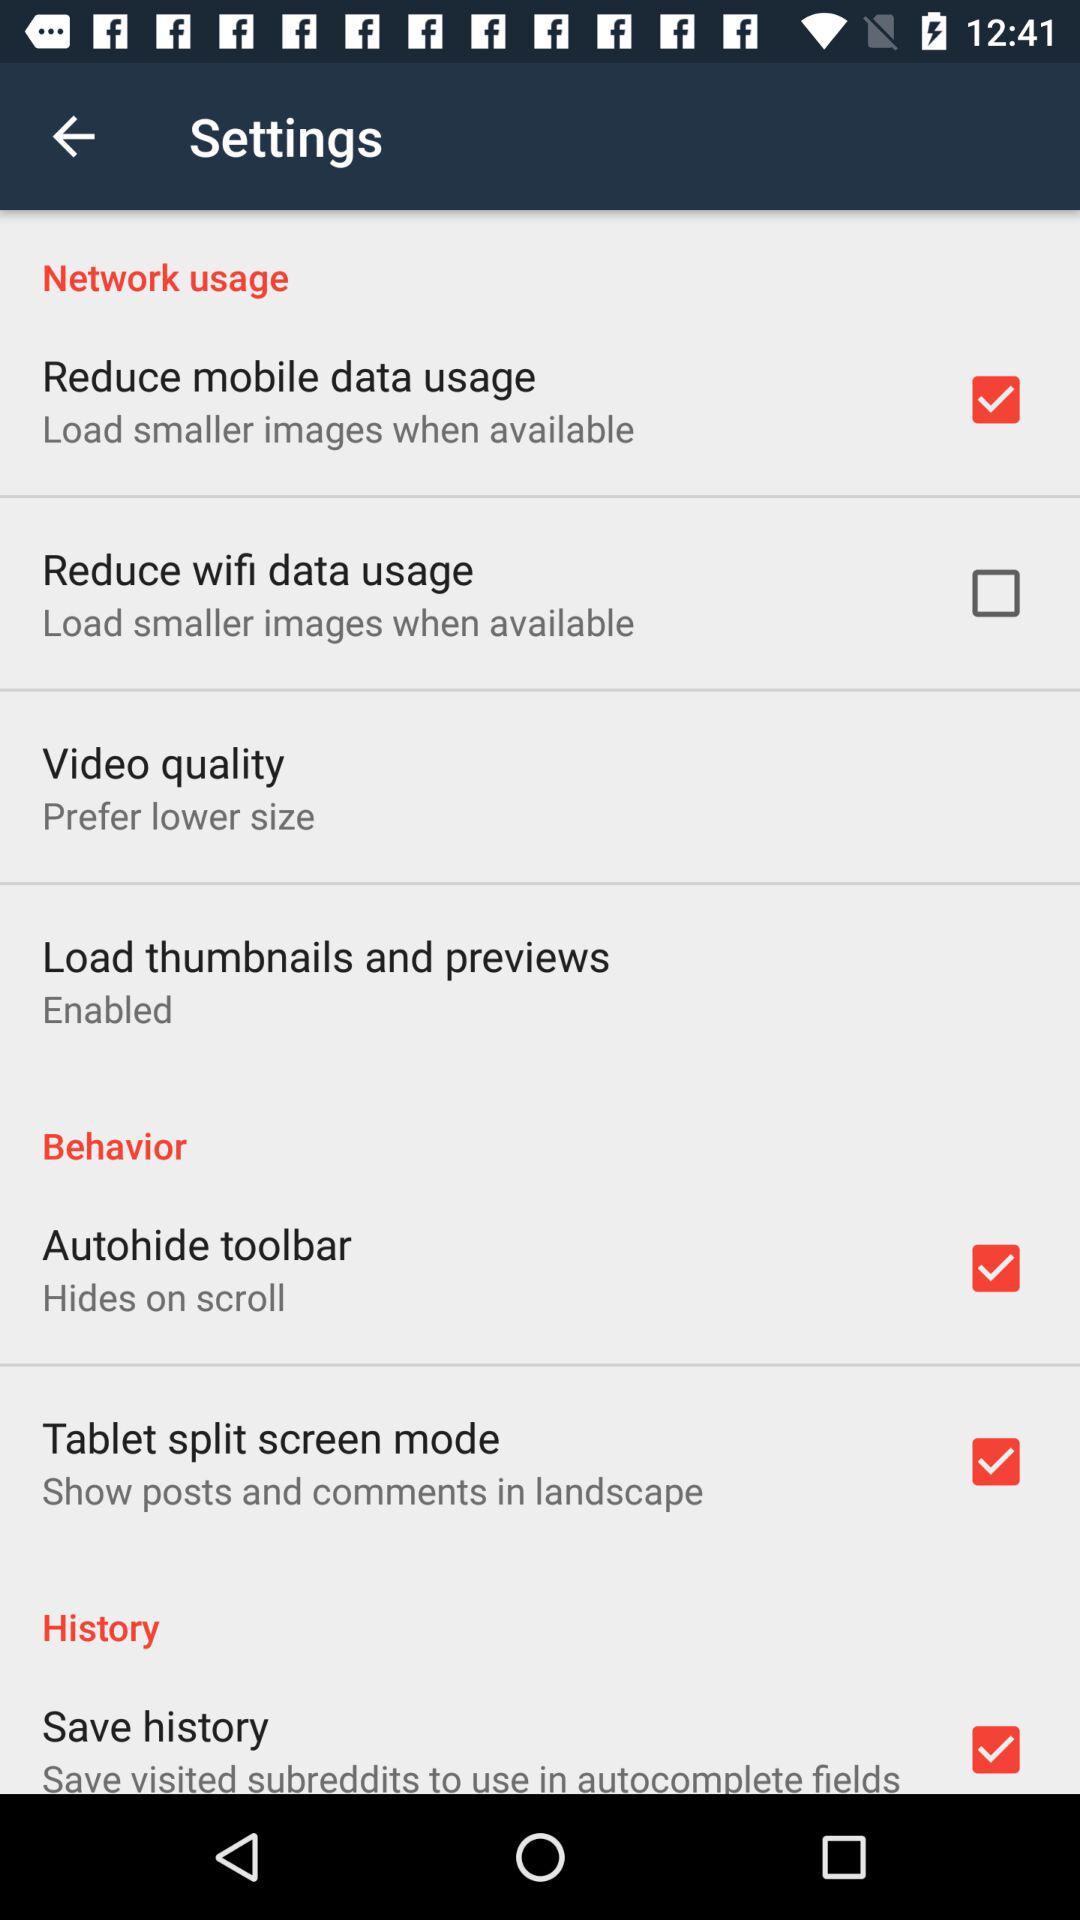Which section has more items, history or behavior?
Answer the question using a single word or phrase. Behavior 